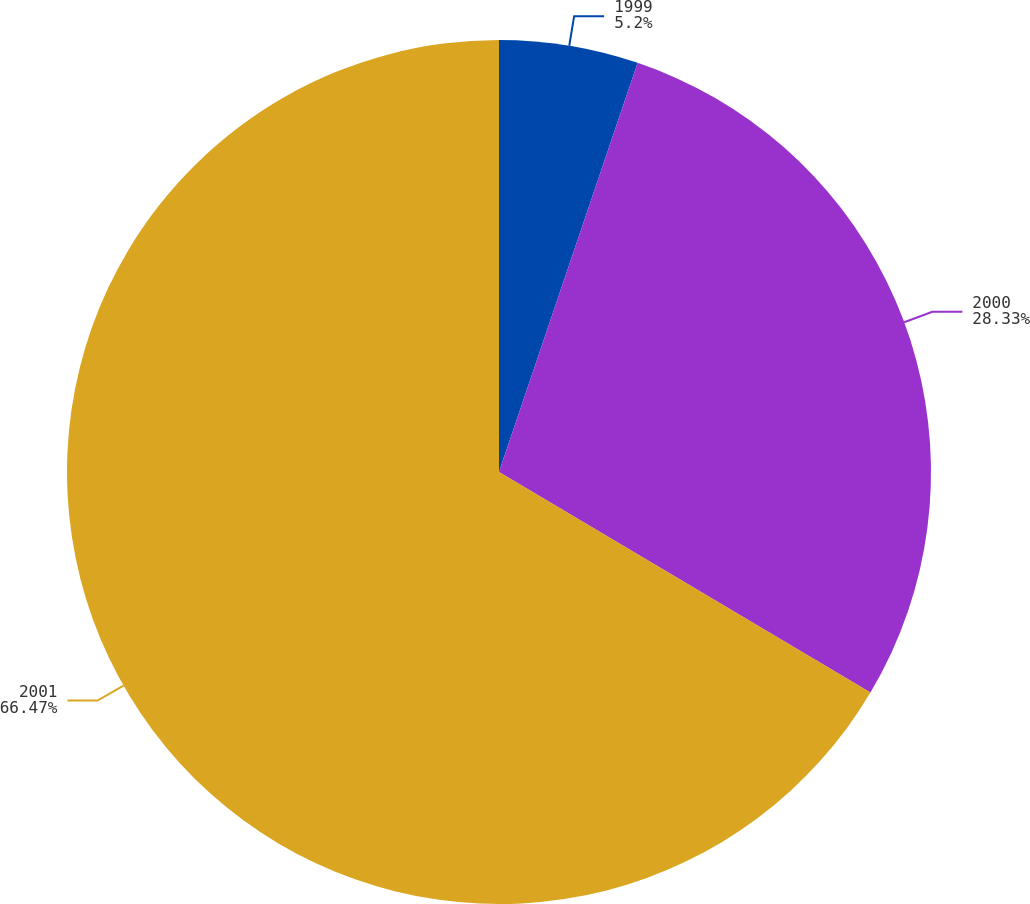Convert chart to OTSL. <chart><loc_0><loc_0><loc_500><loc_500><pie_chart><fcel>1999<fcel>2000<fcel>2001<nl><fcel>5.2%<fcel>28.33%<fcel>66.47%<nl></chart> 